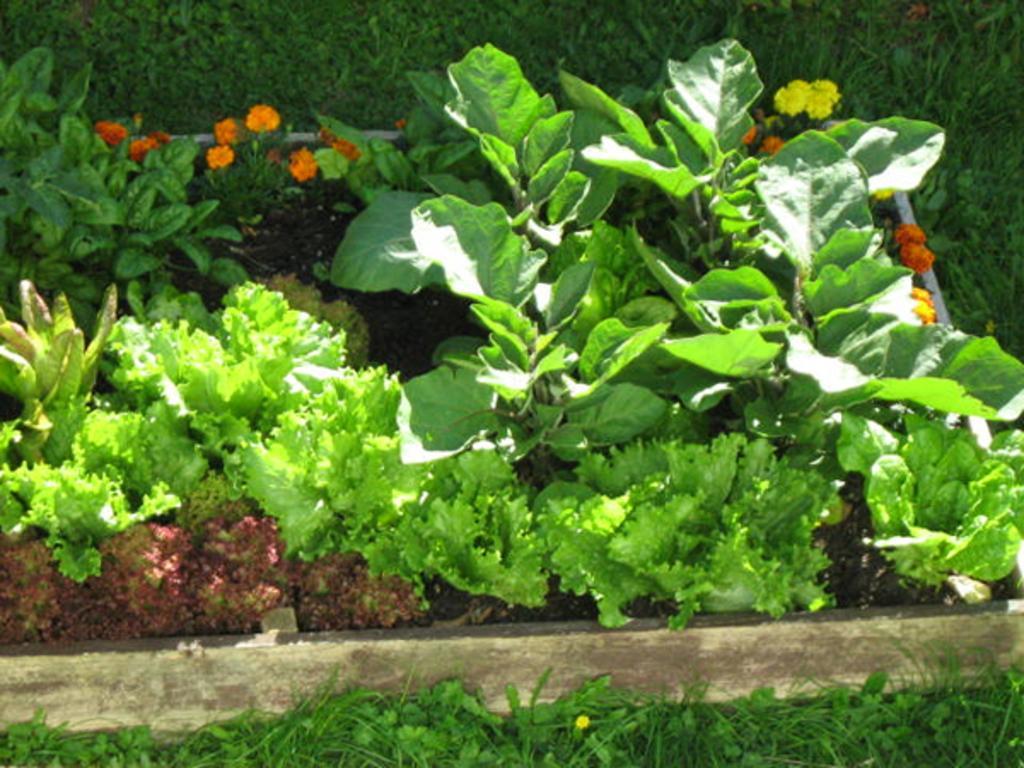Please provide a concise description of this image. In this picture we can see some flowers and plants from left to right. 